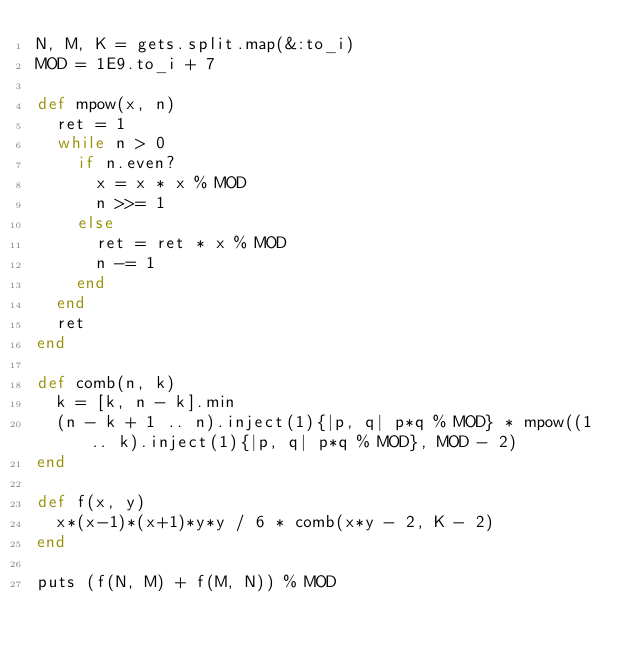<code> <loc_0><loc_0><loc_500><loc_500><_Ruby_>N, M, K = gets.split.map(&:to_i)
MOD = 1E9.to_i + 7

def mpow(x, n)
  ret = 1
  while n > 0
    if n.even?
      x = x * x % MOD
      n >>= 1
    else
      ret = ret * x % MOD
      n -= 1
    end
  end
  ret
end

def comb(n, k)
  k = [k, n - k].min
  (n - k + 1 .. n).inject(1){|p, q| p*q % MOD} * mpow((1 .. k).inject(1){|p, q| p*q % MOD}, MOD - 2)
end

def f(x, y)
  x*(x-1)*(x+1)*y*y / 6 * comb(x*y - 2, K - 2)
end

puts (f(N, M) + f(M, N)) % MOD</code> 